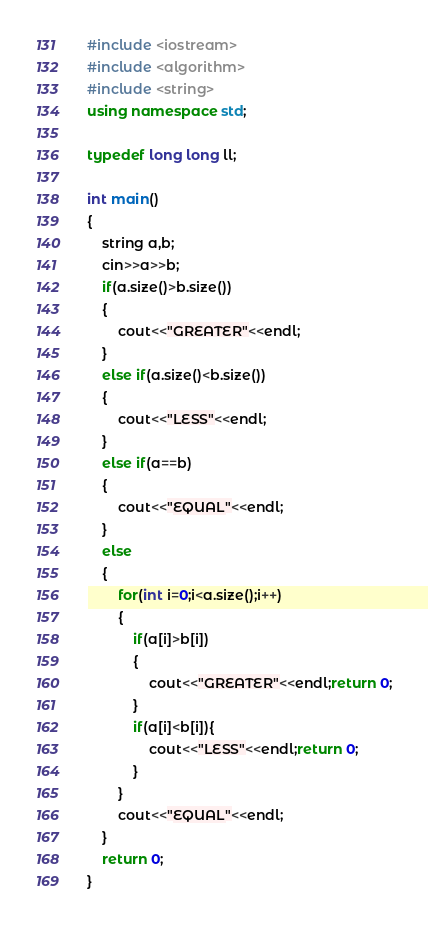<code> <loc_0><loc_0><loc_500><loc_500><_C++_>#include <iostream>
#include <algorithm>
#include <string> 
using namespace std;

typedef long long ll;

int main()
{
    string a,b;
    cin>>a>>b;
    if(a.size()>b.size())
    {
    	cout<<"GREATER"<<endl;
	}
	else if(a.size()<b.size())
	{
		cout<<"LESS"<<endl;
	}
	else if(a==b)
	{
		cout<<"EQUAL"<<endl;
	}
	else
	{
		for(int i=0;i<a.size();i++)
		{
			if(a[i]>b[i])
			{
				cout<<"GREATER"<<endl;return 0;
			}
			if(a[i]<b[i]){
				cout<<"LESS"<<endl;return 0;
			}
		}
		cout<<"EQUAL"<<endl;
	}
    return 0;
}
</code> 